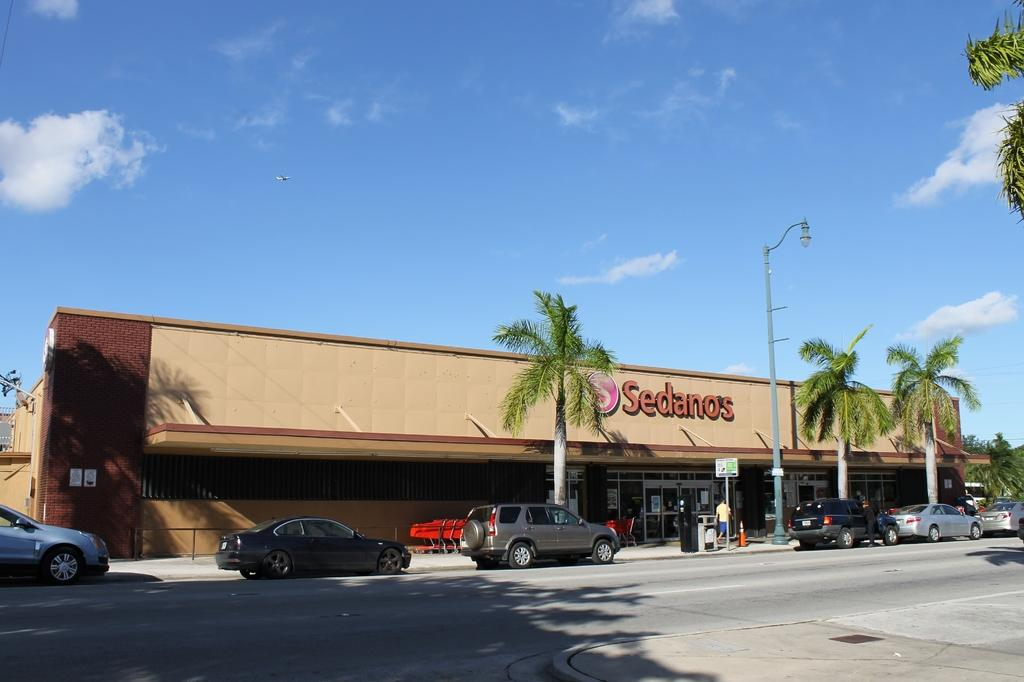What type of vehicles can be seen on the road in the image? There are cars on the road in the image. What type of structure is present in the image? There is a building in the image. What objects are present in the image that are used for supporting or holding something? There are poles in the image. What type of vegetation is present in the image? There are trees in the image. What type of objects are present in the image that are used for displaying information or advertisements? There are boards and posters in the image. What is visible in the background of the image? The sky is visible in the background of the image. What type of weather can be inferred from the image? There are clouds in the sky, which suggests that it might be a partly cloudy day. Can you tell me how many people are sleeping in the bedroom in the image? There is no bedroom present in the image, so it is not possible to determine how many people might be sleeping in it. 